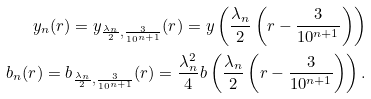Convert formula to latex. <formula><loc_0><loc_0><loc_500><loc_500>y _ { n } ( r ) = y _ { \frac { \lambda _ { n } } { 2 } , \frac { 3 } { 1 0 ^ { n + 1 } } } ( r ) = y \left ( \frac { \lambda _ { n } } { 2 } \left ( r - \frac { 3 } { 1 0 ^ { n + 1 } } \right ) \right ) \\ b _ { n } ( r ) = b _ { \frac { \lambda _ { n } } { 2 } , \frac { 3 } { 1 0 ^ { n + 1 } } } ( r ) = \frac { \lambda _ { n } ^ { 2 } } { 4 } b \left ( \frac { \lambda _ { n } } { 2 } \left ( r - \frac { 3 } { 1 0 ^ { n + 1 } } \right ) \right ) .</formula> 